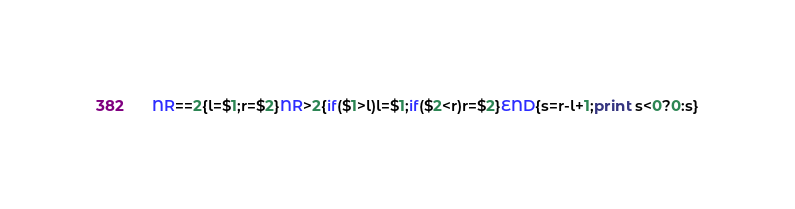Convert code to text. <code><loc_0><loc_0><loc_500><loc_500><_Awk_>NR==2{l=$1;r=$2}NR>2{if($1>l)l=$1;if($2<r)r=$2}END{s=r-l+1;print s<0?0:s}</code> 